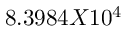<formula> <loc_0><loc_0><loc_500><loc_500>8 . 3 9 8 4 X 1 0 ^ { 4 }</formula> 